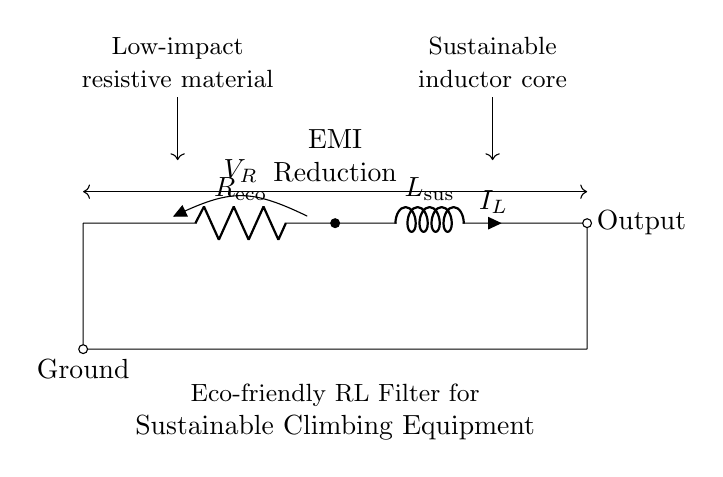What is the type of filter shown in the circuit diagram? The circuit diagram represents an RL filter, which consists of a resistor and an inductor connected in series. This configuration is typically used for filtering purposes to reduce electromagnetic interference.
Answer: RL filter What does the resistor symbolize in this context? The resistor in the circuit is labeled as R eco, indicating that it is made from low-impact resistive material, which is an eco-friendly choice suitable for sustainable climbing gear.
Answer: Low-impact resistive material What is the function of the inductor in the circuit? The inductor, labeled L sus, serves to store energy in a magnetic field when current flows, helping to filter out high-frequency electromagnetic signals, thus contributing to electromagnetic interference reduction.
Answer: Sustainable inductor core How does the circuit contribute to EMI reduction? The RL filter configuration enables the attenuation of high-frequency noise or interference signals, effectively reducing electromagnetic interference (EMI) that may affect the performance and safety of climbing gear.
Answer: EMI reduction What is the significance of the output in the circuit? The output represents the point where the filtered signal is available for further use, ensuring that the affected equipment operates reliably with reduced EMI, which is crucial for the safety and performance of climbing gear.
Answer: Output What is the total resistance in this circuit when in operation? The total resistance is represented by the value of R eco, as there is only one resistor in the series with the inductor. Therefore, the total resistance directly corresponds to the value of the eco-friendly resistor used.
Answer: R eco What core material should the inductor ideally use? The sustainable inductor core suggests the use of eco-friendly materials that reduce environmental impact, aligning with the overall goal of sustainable manufacturing processes in climbing gear production.
Answer: Sustainable inductor core 